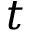Convert formula to latex. <formula><loc_0><loc_0><loc_500><loc_500>t</formula> 